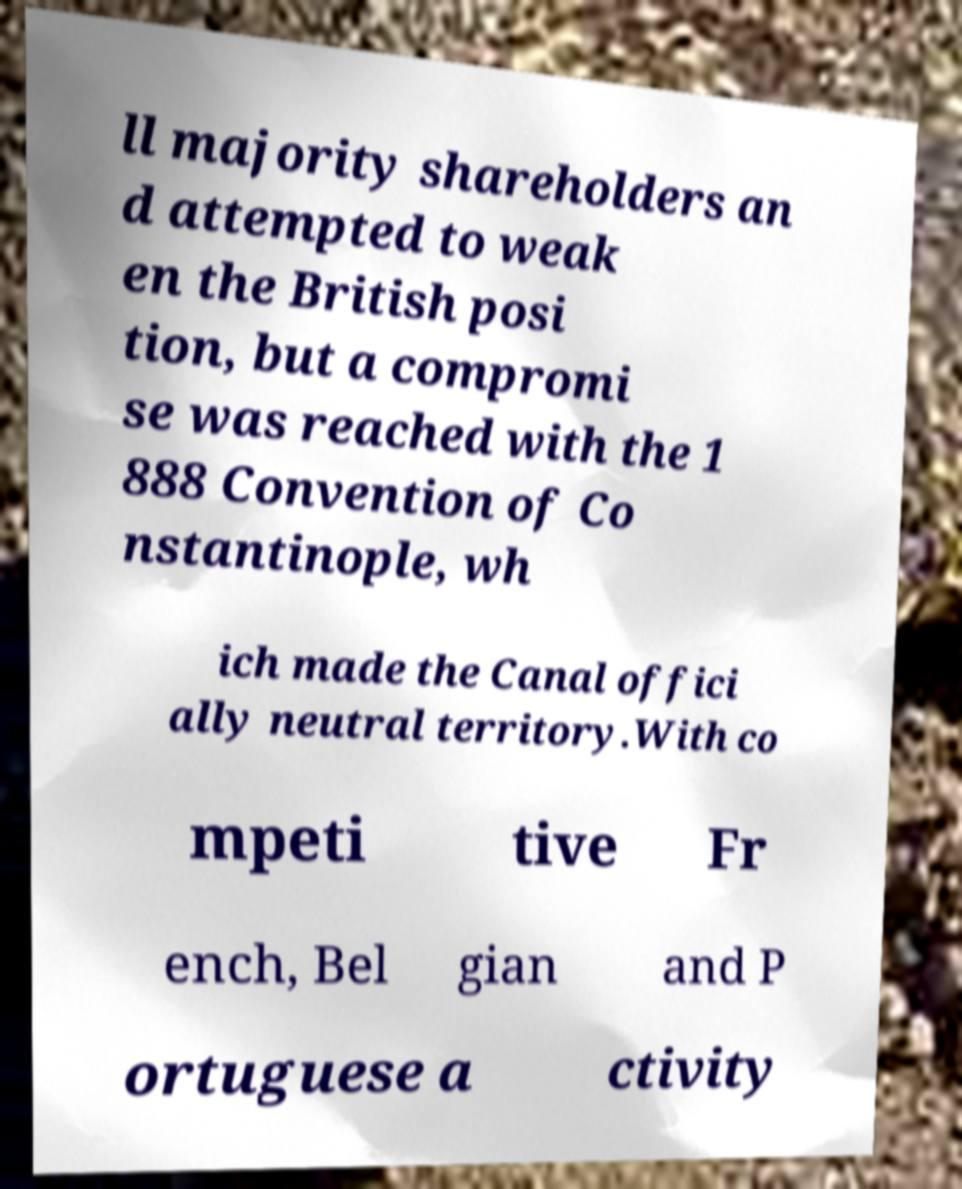Could you assist in decoding the text presented in this image and type it out clearly? ll majority shareholders an d attempted to weak en the British posi tion, but a compromi se was reached with the 1 888 Convention of Co nstantinople, wh ich made the Canal offici ally neutral territory.With co mpeti tive Fr ench, Bel gian and P ortuguese a ctivity 